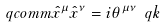Convert formula to latex. <formula><loc_0><loc_0><loc_500><loc_500>\ q c o m m { \hat { x } ^ { \mu } } { \hat { x } ^ { \nu } } = i \theta ^ { \mu \nu } \ q k</formula> 